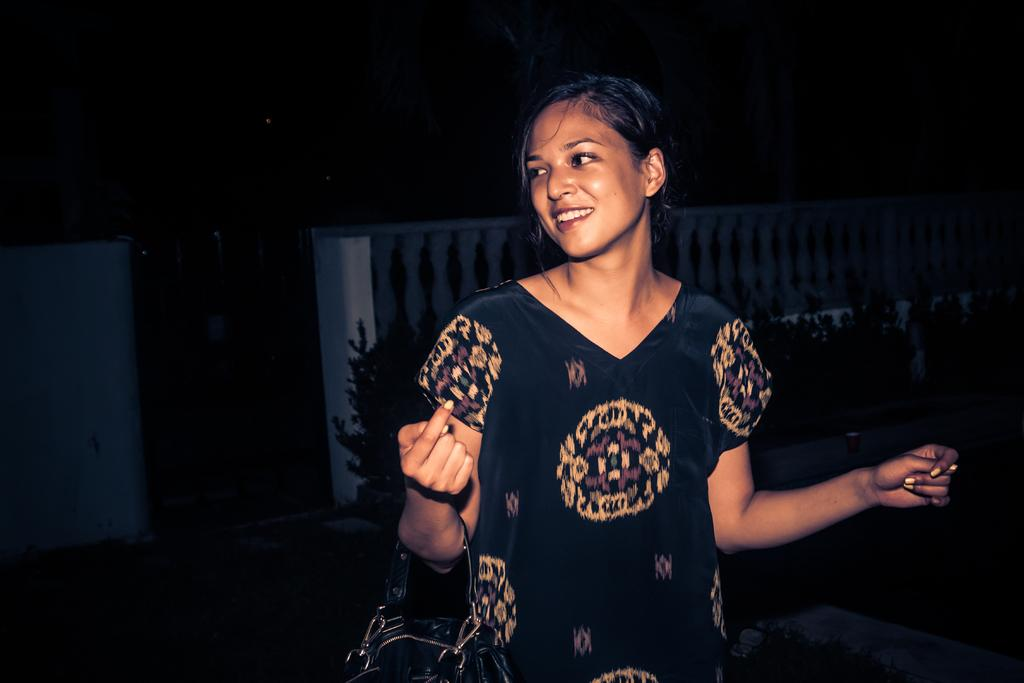Who is present in the image? There is a lady in the image. What is the lady holding in the image? The lady is holding a bag. What can be seen behind the lady in the image? There are plants visible behind the lady. What type of barrier is present in the image? There is a fence in the image. How many pies can be seen on the fence in the image? There are no pies present in the image, and the fence does not have any pies on it. 